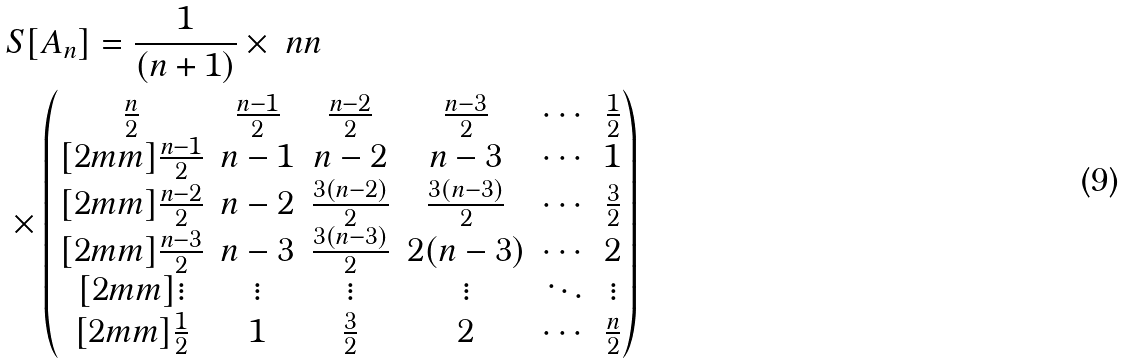Convert formula to latex. <formula><loc_0><loc_0><loc_500><loc_500>& S [ A _ { n } ] = \frac { 1 } { ( n + 1 ) } \times \ n n \\ & \times \begin{pmatrix} \frac { n } { 2 } & \frac { n - 1 } { 2 } & \frac { n - 2 } { 2 } & \frac { n - 3 } { 2 } & \cdots & \frac { 1 } { 2 } \\ [ 2 m m ] \frac { n - 1 } { 2 } & n - 1 & n - 2 & n - 3 & \cdots & 1 \\ [ 2 m m ] \frac { n - 2 } { 2 } & n - 2 & \frac { 3 ( n - 2 ) } { 2 } & \frac { 3 ( n - 3 ) } { 2 } & \cdots & \frac { 3 } { 2 } \\ [ 2 m m ] \frac { n - 3 } { 2 } & n - 3 & \frac { 3 ( n - 3 ) } { 2 } & 2 ( n - 3 ) & \cdots & 2 \\ [ 2 m m ] \vdots & \vdots & \vdots & \vdots & \ddots & \vdots \\ [ 2 m m ] \frac { 1 } { 2 } & 1 & \frac { 3 } { 2 } & 2 & \cdots & \frac { n } { 2 } \end{pmatrix}</formula> 